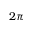<formula> <loc_0><loc_0><loc_500><loc_500>2 \pi</formula> 